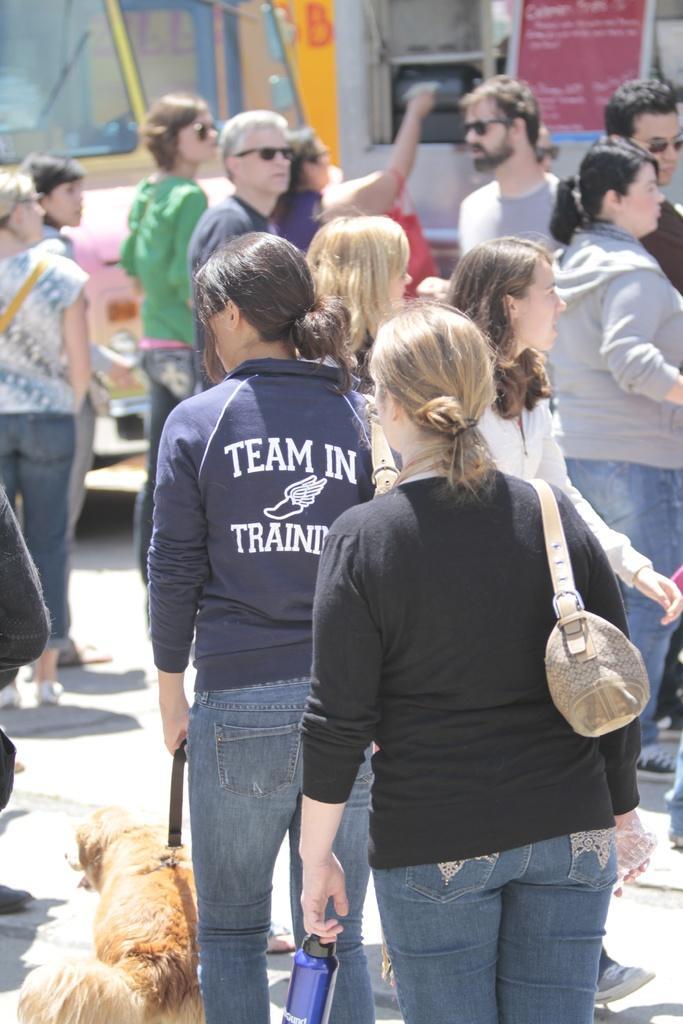How would you summarize this image in a sentence or two? There are several people walking and standing on the road. There is a woman holding a dog in her hand wearing a blue t shirt. In the background there is a vehicle. One of the woman is holding the bag on her shoulder with a black t shirt. 